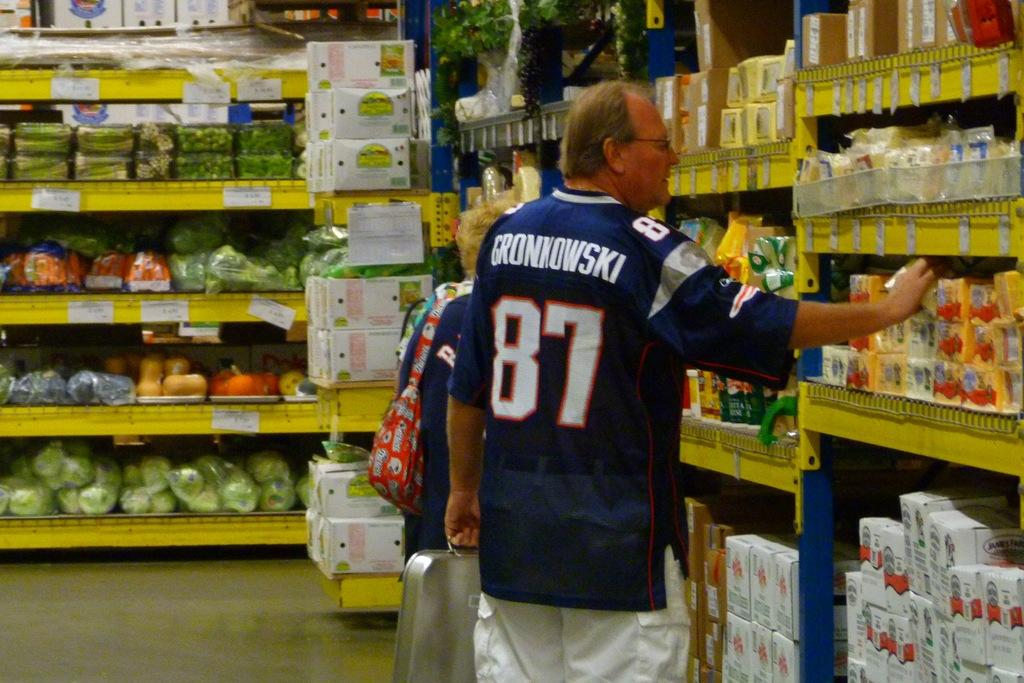Provide a one-sentence caption for the provided image. A man in the supermarket wearing a Grownwokski football jersey. 